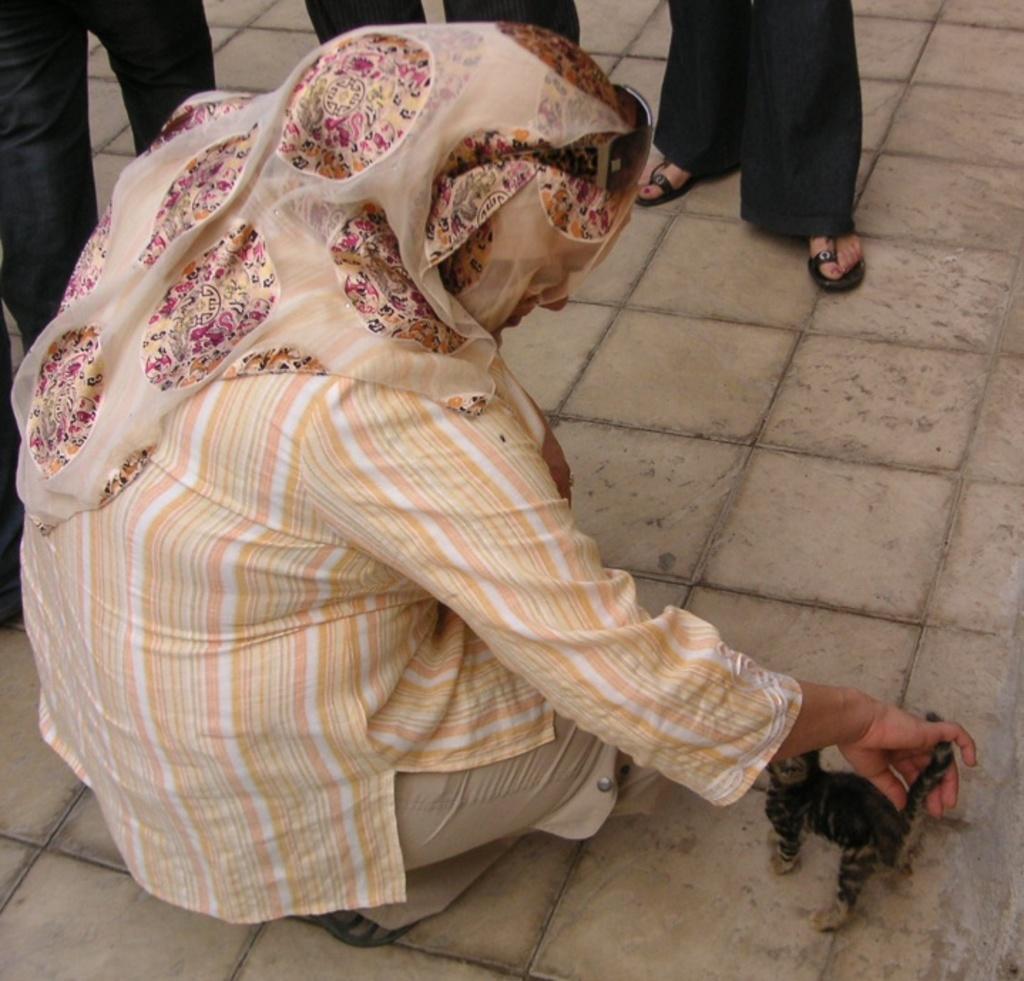Please provide a concise description of this image. In this picture we can see a person is holding something in the front, in the background there are some people standing, at the bottom we can see tiles. 